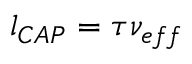Convert formula to latex. <formula><loc_0><loc_0><loc_500><loc_500>l _ { C A P } = \tau \nu _ { e f f }</formula> 